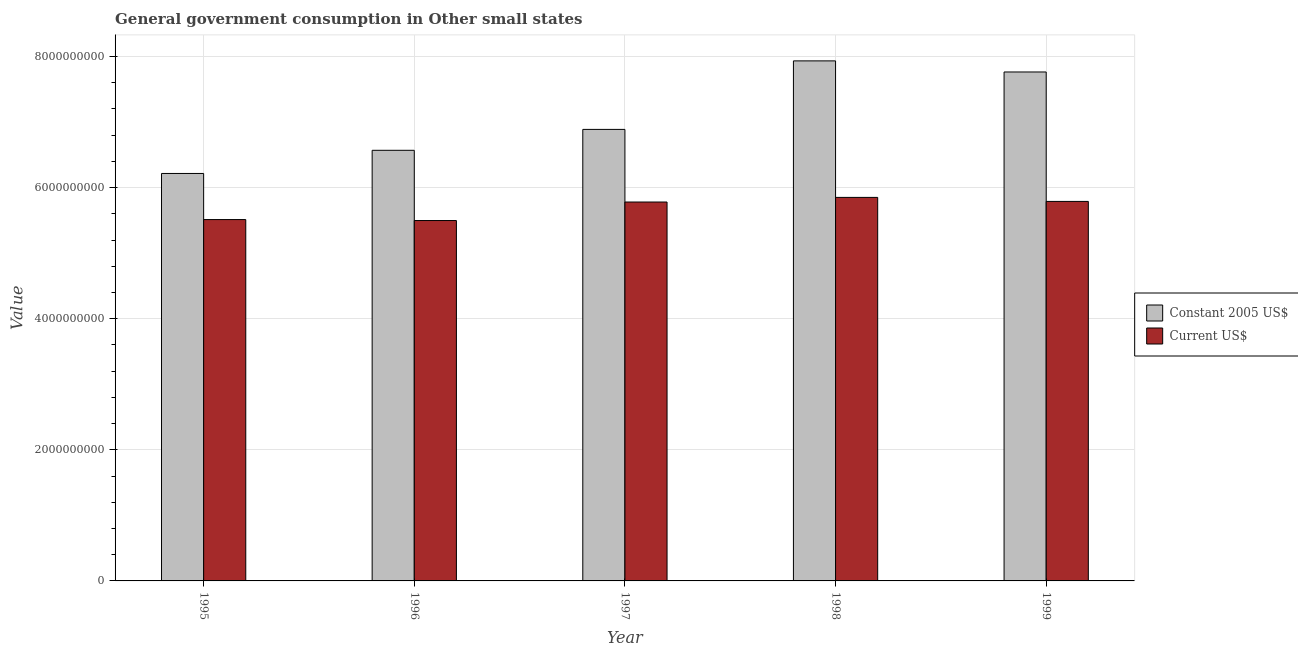How many different coloured bars are there?
Your answer should be very brief. 2. How many bars are there on the 4th tick from the left?
Your answer should be very brief. 2. What is the label of the 3rd group of bars from the left?
Offer a very short reply. 1997. What is the value consumed in current us$ in 1997?
Provide a short and direct response. 5.78e+09. Across all years, what is the maximum value consumed in current us$?
Keep it short and to the point. 5.85e+09. Across all years, what is the minimum value consumed in constant 2005 us$?
Keep it short and to the point. 6.22e+09. In which year was the value consumed in constant 2005 us$ maximum?
Provide a succinct answer. 1998. In which year was the value consumed in constant 2005 us$ minimum?
Provide a succinct answer. 1995. What is the total value consumed in constant 2005 us$ in the graph?
Provide a succinct answer. 3.54e+1. What is the difference between the value consumed in constant 2005 us$ in 1996 and that in 1998?
Make the answer very short. -1.36e+09. What is the difference between the value consumed in constant 2005 us$ in 1997 and the value consumed in current us$ in 1998?
Provide a succinct answer. -1.05e+09. What is the average value consumed in current us$ per year?
Make the answer very short. 5.69e+09. In the year 1995, what is the difference between the value consumed in current us$ and value consumed in constant 2005 us$?
Your response must be concise. 0. What is the ratio of the value consumed in constant 2005 us$ in 1995 to that in 1997?
Offer a terse response. 0.9. Is the value consumed in constant 2005 us$ in 1995 less than that in 1998?
Keep it short and to the point. Yes. Is the difference between the value consumed in constant 2005 us$ in 1995 and 1998 greater than the difference between the value consumed in current us$ in 1995 and 1998?
Ensure brevity in your answer.  No. What is the difference between the highest and the second highest value consumed in constant 2005 us$?
Offer a terse response. 1.69e+08. What is the difference between the highest and the lowest value consumed in current us$?
Make the answer very short. 3.53e+08. In how many years, is the value consumed in constant 2005 us$ greater than the average value consumed in constant 2005 us$ taken over all years?
Provide a short and direct response. 2. What does the 2nd bar from the left in 1999 represents?
Provide a short and direct response. Current US$. What does the 2nd bar from the right in 1995 represents?
Ensure brevity in your answer.  Constant 2005 US$. How many bars are there?
Ensure brevity in your answer.  10. Are all the bars in the graph horizontal?
Provide a short and direct response. No. What is the difference between two consecutive major ticks on the Y-axis?
Your answer should be very brief. 2.00e+09. Where does the legend appear in the graph?
Provide a succinct answer. Center right. How many legend labels are there?
Your response must be concise. 2. What is the title of the graph?
Offer a very short reply. General government consumption in Other small states. Does "Study and work" appear as one of the legend labels in the graph?
Provide a short and direct response. No. What is the label or title of the Y-axis?
Provide a short and direct response. Value. What is the Value of Constant 2005 US$ in 1995?
Your answer should be very brief. 6.22e+09. What is the Value in Current US$ in 1995?
Your answer should be very brief. 5.51e+09. What is the Value of Constant 2005 US$ in 1996?
Offer a very short reply. 6.57e+09. What is the Value in Current US$ in 1996?
Your answer should be very brief. 5.50e+09. What is the Value of Constant 2005 US$ in 1997?
Provide a short and direct response. 6.89e+09. What is the Value in Current US$ in 1997?
Your answer should be compact. 5.78e+09. What is the Value of Constant 2005 US$ in 1998?
Ensure brevity in your answer.  7.93e+09. What is the Value of Current US$ in 1998?
Make the answer very short. 5.85e+09. What is the Value in Constant 2005 US$ in 1999?
Provide a succinct answer. 7.76e+09. What is the Value of Current US$ in 1999?
Offer a terse response. 5.79e+09. Across all years, what is the maximum Value in Constant 2005 US$?
Keep it short and to the point. 7.93e+09. Across all years, what is the maximum Value of Current US$?
Offer a very short reply. 5.85e+09. Across all years, what is the minimum Value of Constant 2005 US$?
Give a very brief answer. 6.22e+09. Across all years, what is the minimum Value of Current US$?
Provide a succinct answer. 5.50e+09. What is the total Value in Constant 2005 US$ in the graph?
Offer a terse response. 3.54e+1. What is the total Value of Current US$ in the graph?
Provide a short and direct response. 2.84e+1. What is the difference between the Value of Constant 2005 US$ in 1995 and that in 1996?
Provide a succinct answer. -3.53e+08. What is the difference between the Value in Current US$ in 1995 and that in 1996?
Offer a terse response. 1.47e+07. What is the difference between the Value in Constant 2005 US$ in 1995 and that in 1997?
Your answer should be very brief. -6.72e+08. What is the difference between the Value in Current US$ in 1995 and that in 1997?
Your response must be concise. -2.68e+08. What is the difference between the Value in Constant 2005 US$ in 1995 and that in 1998?
Give a very brief answer. -1.72e+09. What is the difference between the Value in Current US$ in 1995 and that in 1998?
Give a very brief answer. -3.38e+08. What is the difference between the Value of Constant 2005 US$ in 1995 and that in 1999?
Your answer should be very brief. -1.55e+09. What is the difference between the Value in Current US$ in 1995 and that in 1999?
Your answer should be compact. -2.77e+08. What is the difference between the Value of Constant 2005 US$ in 1996 and that in 1997?
Make the answer very short. -3.19e+08. What is the difference between the Value of Current US$ in 1996 and that in 1997?
Keep it short and to the point. -2.82e+08. What is the difference between the Value in Constant 2005 US$ in 1996 and that in 1998?
Your response must be concise. -1.36e+09. What is the difference between the Value in Current US$ in 1996 and that in 1998?
Your answer should be very brief. -3.53e+08. What is the difference between the Value in Constant 2005 US$ in 1996 and that in 1999?
Provide a succinct answer. -1.19e+09. What is the difference between the Value of Current US$ in 1996 and that in 1999?
Provide a short and direct response. -2.92e+08. What is the difference between the Value in Constant 2005 US$ in 1997 and that in 1998?
Make the answer very short. -1.05e+09. What is the difference between the Value of Current US$ in 1997 and that in 1998?
Give a very brief answer. -7.07e+07. What is the difference between the Value in Constant 2005 US$ in 1997 and that in 1999?
Your answer should be compact. -8.76e+08. What is the difference between the Value in Current US$ in 1997 and that in 1999?
Your answer should be very brief. -9.51e+06. What is the difference between the Value in Constant 2005 US$ in 1998 and that in 1999?
Offer a terse response. 1.69e+08. What is the difference between the Value of Current US$ in 1998 and that in 1999?
Your answer should be compact. 6.12e+07. What is the difference between the Value of Constant 2005 US$ in 1995 and the Value of Current US$ in 1996?
Your response must be concise. 7.18e+08. What is the difference between the Value in Constant 2005 US$ in 1995 and the Value in Current US$ in 1997?
Your answer should be very brief. 4.36e+08. What is the difference between the Value of Constant 2005 US$ in 1995 and the Value of Current US$ in 1998?
Give a very brief answer. 3.65e+08. What is the difference between the Value in Constant 2005 US$ in 1995 and the Value in Current US$ in 1999?
Your response must be concise. 4.26e+08. What is the difference between the Value in Constant 2005 US$ in 1996 and the Value in Current US$ in 1997?
Your answer should be very brief. 7.89e+08. What is the difference between the Value of Constant 2005 US$ in 1996 and the Value of Current US$ in 1998?
Make the answer very short. 7.18e+08. What is the difference between the Value of Constant 2005 US$ in 1996 and the Value of Current US$ in 1999?
Provide a short and direct response. 7.79e+08. What is the difference between the Value in Constant 2005 US$ in 1997 and the Value in Current US$ in 1998?
Give a very brief answer. 1.04e+09. What is the difference between the Value in Constant 2005 US$ in 1997 and the Value in Current US$ in 1999?
Make the answer very short. 1.10e+09. What is the difference between the Value in Constant 2005 US$ in 1998 and the Value in Current US$ in 1999?
Offer a very short reply. 2.14e+09. What is the average Value of Constant 2005 US$ per year?
Provide a short and direct response. 7.07e+09. What is the average Value of Current US$ per year?
Your answer should be very brief. 5.69e+09. In the year 1995, what is the difference between the Value of Constant 2005 US$ and Value of Current US$?
Your answer should be compact. 7.03e+08. In the year 1996, what is the difference between the Value of Constant 2005 US$ and Value of Current US$?
Make the answer very short. 1.07e+09. In the year 1997, what is the difference between the Value of Constant 2005 US$ and Value of Current US$?
Your answer should be very brief. 1.11e+09. In the year 1998, what is the difference between the Value in Constant 2005 US$ and Value in Current US$?
Offer a very short reply. 2.08e+09. In the year 1999, what is the difference between the Value in Constant 2005 US$ and Value in Current US$?
Your answer should be very brief. 1.97e+09. What is the ratio of the Value in Constant 2005 US$ in 1995 to that in 1996?
Make the answer very short. 0.95. What is the ratio of the Value in Current US$ in 1995 to that in 1996?
Your answer should be compact. 1. What is the ratio of the Value of Constant 2005 US$ in 1995 to that in 1997?
Provide a short and direct response. 0.9. What is the ratio of the Value of Current US$ in 1995 to that in 1997?
Make the answer very short. 0.95. What is the ratio of the Value in Constant 2005 US$ in 1995 to that in 1998?
Keep it short and to the point. 0.78. What is the ratio of the Value of Current US$ in 1995 to that in 1998?
Provide a short and direct response. 0.94. What is the ratio of the Value in Constant 2005 US$ in 1995 to that in 1999?
Ensure brevity in your answer.  0.8. What is the ratio of the Value in Current US$ in 1995 to that in 1999?
Make the answer very short. 0.95. What is the ratio of the Value of Constant 2005 US$ in 1996 to that in 1997?
Keep it short and to the point. 0.95. What is the ratio of the Value in Current US$ in 1996 to that in 1997?
Your answer should be very brief. 0.95. What is the ratio of the Value in Constant 2005 US$ in 1996 to that in 1998?
Offer a very short reply. 0.83. What is the ratio of the Value of Current US$ in 1996 to that in 1998?
Give a very brief answer. 0.94. What is the ratio of the Value of Constant 2005 US$ in 1996 to that in 1999?
Your response must be concise. 0.85. What is the ratio of the Value in Current US$ in 1996 to that in 1999?
Provide a succinct answer. 0.95. What is the ratio of the Value of Constant 2005 US$ in 1997 to that in 1998?
Offer a terse response. 0.87. What is the ratio of the Value of Current US$ in 1997 to that in 1998?
Offer a terse response. 0.99. What is the ratio of the Value of Constant 2005 US$ in 1997 to that in 1999?
Your answer should be very brief. 0.89. What is the ratio of the Value in Constant 2005 US$ in 1998 to that in 1999?
Your answer should be compact. 1.02. What is the ratio of the Value in Current US$ in 1998 to that in 1999?
Give a very brief answer. 1.01. What is the difference between the highest and the second highest Value of Constant 2005 US$?
Your answer should be compact. 1.69e+08. What is the difference between the highest and the second highest Value in Current US$?
Make the answer very short. 6.12e+07. What is the difference between the highest and the lowest Value of Constant 2005 US$?
Make the answer very short. 1.72e+09. What is the difference between the highest and the lowest Value of Current US$?
Make the answer very short. 3.53e+08. 